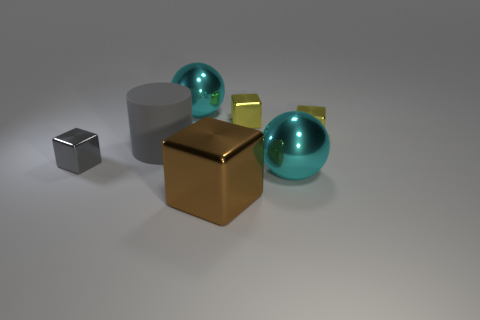What number of small shiny cubes are the same color as the rubber cylinder?
Provide a short and direct response. 1. The brown object that is made of the same material as the tiny gray object is what size?
Give a very brief answer. Large. The tiny shiny object that is the same color as the rubber cylinder is what shape?
Keep it short and to the point. Cube. How many large cyan spheres are behind the big metallic block?
Keep it short and to the point. 2. Does the rubber thing have the same shape as the big brown thing?
Give a very brief answer. No. How many big cyan things are both behind the gray shiny object and in front of the gray cube?
Ensure brevity in your answer.  0. How many things are big red metal cubes or cyan metal balls right of the cylinder?
Provide a succinct answer. 2. Is the number of yellow cubes greater than the number of gray metal cubes?
Your answer should be very brief. Yes. What shape is the big cyan thing that is behind the gray metallic cube?
Provide a succinct answer. Sphere. What number of brown things have the same shape as the small gray object?
Make the answer very short. 1. 